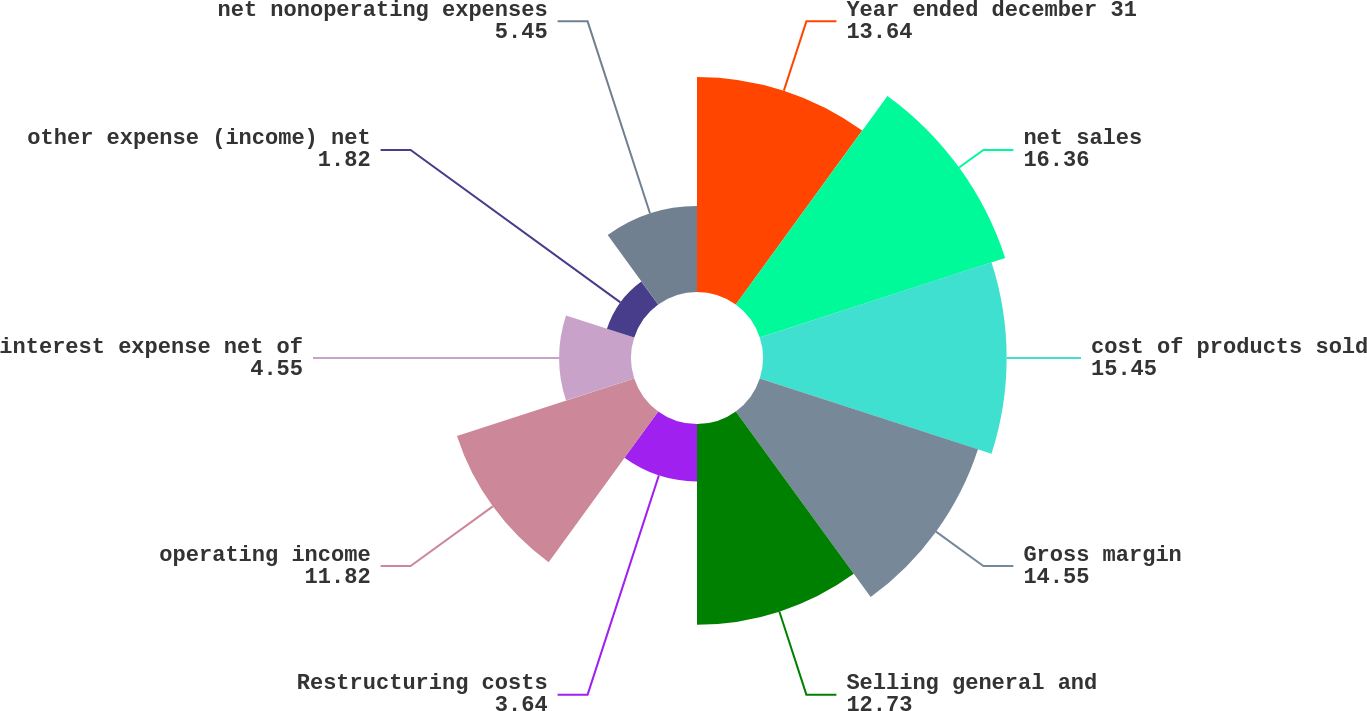Convert chart to OTSL. <chart><loc_0><loc_0><loc_500><loc_500><pie_chart><fcel>Year ended december 31<fcel>net sales<fcel>cost of products sold<fcel>Gross margin<fcel>Selling general and<fcel>Restructuring costs<fcel>operating income<fcel>interest expense net of<fcel>other expense (income) net<fcel>net nonoperating expenses<nl><fcel>13.64%<fcel>16.36%<fcel>15.45%<fcel>14.55%<fcel>12.73%<fcel>3.64%<fcel>11.82%<fcel>4.55%<fcel>1.82%<fcel>5.45%<nl></chart> 